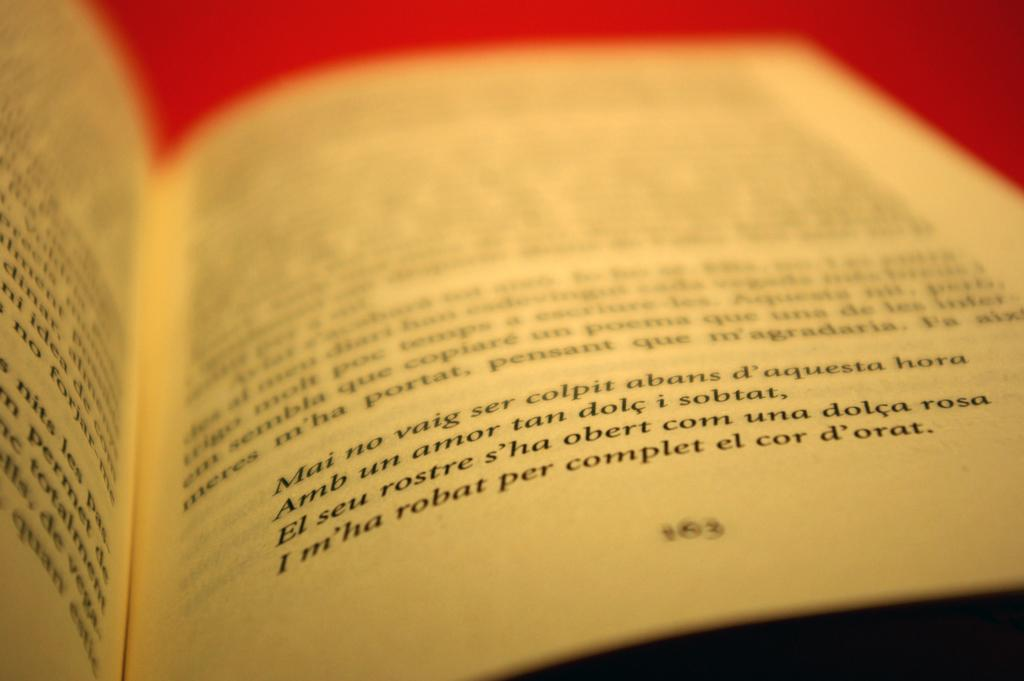<image>
Summarize the visual content of the image. A book is open to page 163 and the chapter mentions d'orat. 